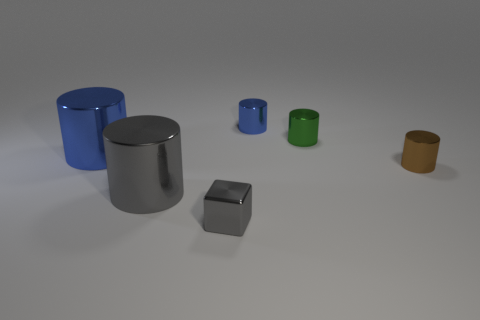What size is the shiny thing that is the same color as the block?
Offer a terse response. Large. There is a metallic thing that is on the left side of the small blue metallic thing and behind the big gray thing; what size is it?
Keep it short and to the point. Large. How many cylinders are to the right of the big metallic cylinder that is to the right of the object that is to the left of the gray cylinder?
Give a very brief answer. 3. Are there any metallic cylinders that have the same color as the block?
Ensure brevity in your answer.  Yes. What color is the thing that is the same size as the gray shiny cylinder?
Keep it short and to the point. Blue. There is a tiny gray metal thing that is to the right of the blue thing in front of the blue metal object that is to the right of the small cube; what is its shape?
Offer a terse response. Cube. What number of metallic cylinders are behind the large metal cylinder that is behind the tiny brown metal cylinder?
Provide a short and direct response. 2. Does the large object that is behind the small brown cylinder have the same shape as the thing in front of the large gray cylinder?
Your response must be concise. No. There is a small brown metallic object; what number of tiny green shiny cylinders are behind it?
Keep it short and to the point. 1. Do the large object that is behind the small brown cylinder and the small green thing have the same material?
Offer a very short reply. Yes. 